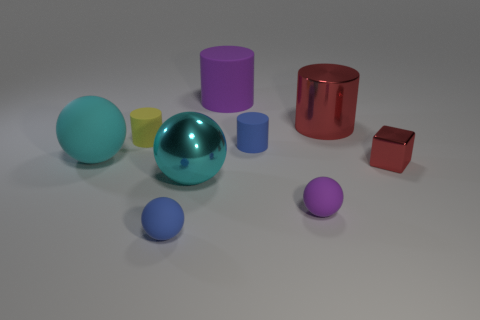Subtract all large metallic cylinders. How many cylinders are left? 3 Subtract all purple balls. How many balls are left? 3 Add 1 large red shiny objects. How many objects exist? 10 Subtract all cylinders. How many objects are left? 5 Add 1 tiny purple spheres. How many tiny purple spheres are left? 2 Add 6 purple matte things. How many purple matte things exist? 8 Subtract 0 green cubes. How many objects are left? 9 Subtract 2 cylinders. How many cylinders are left? 2 Subtract all brown cubes. Subtract all red cylinders. How many cubes are left? 1 Subtract all green cylinders. How many blue spheres are left? 1 